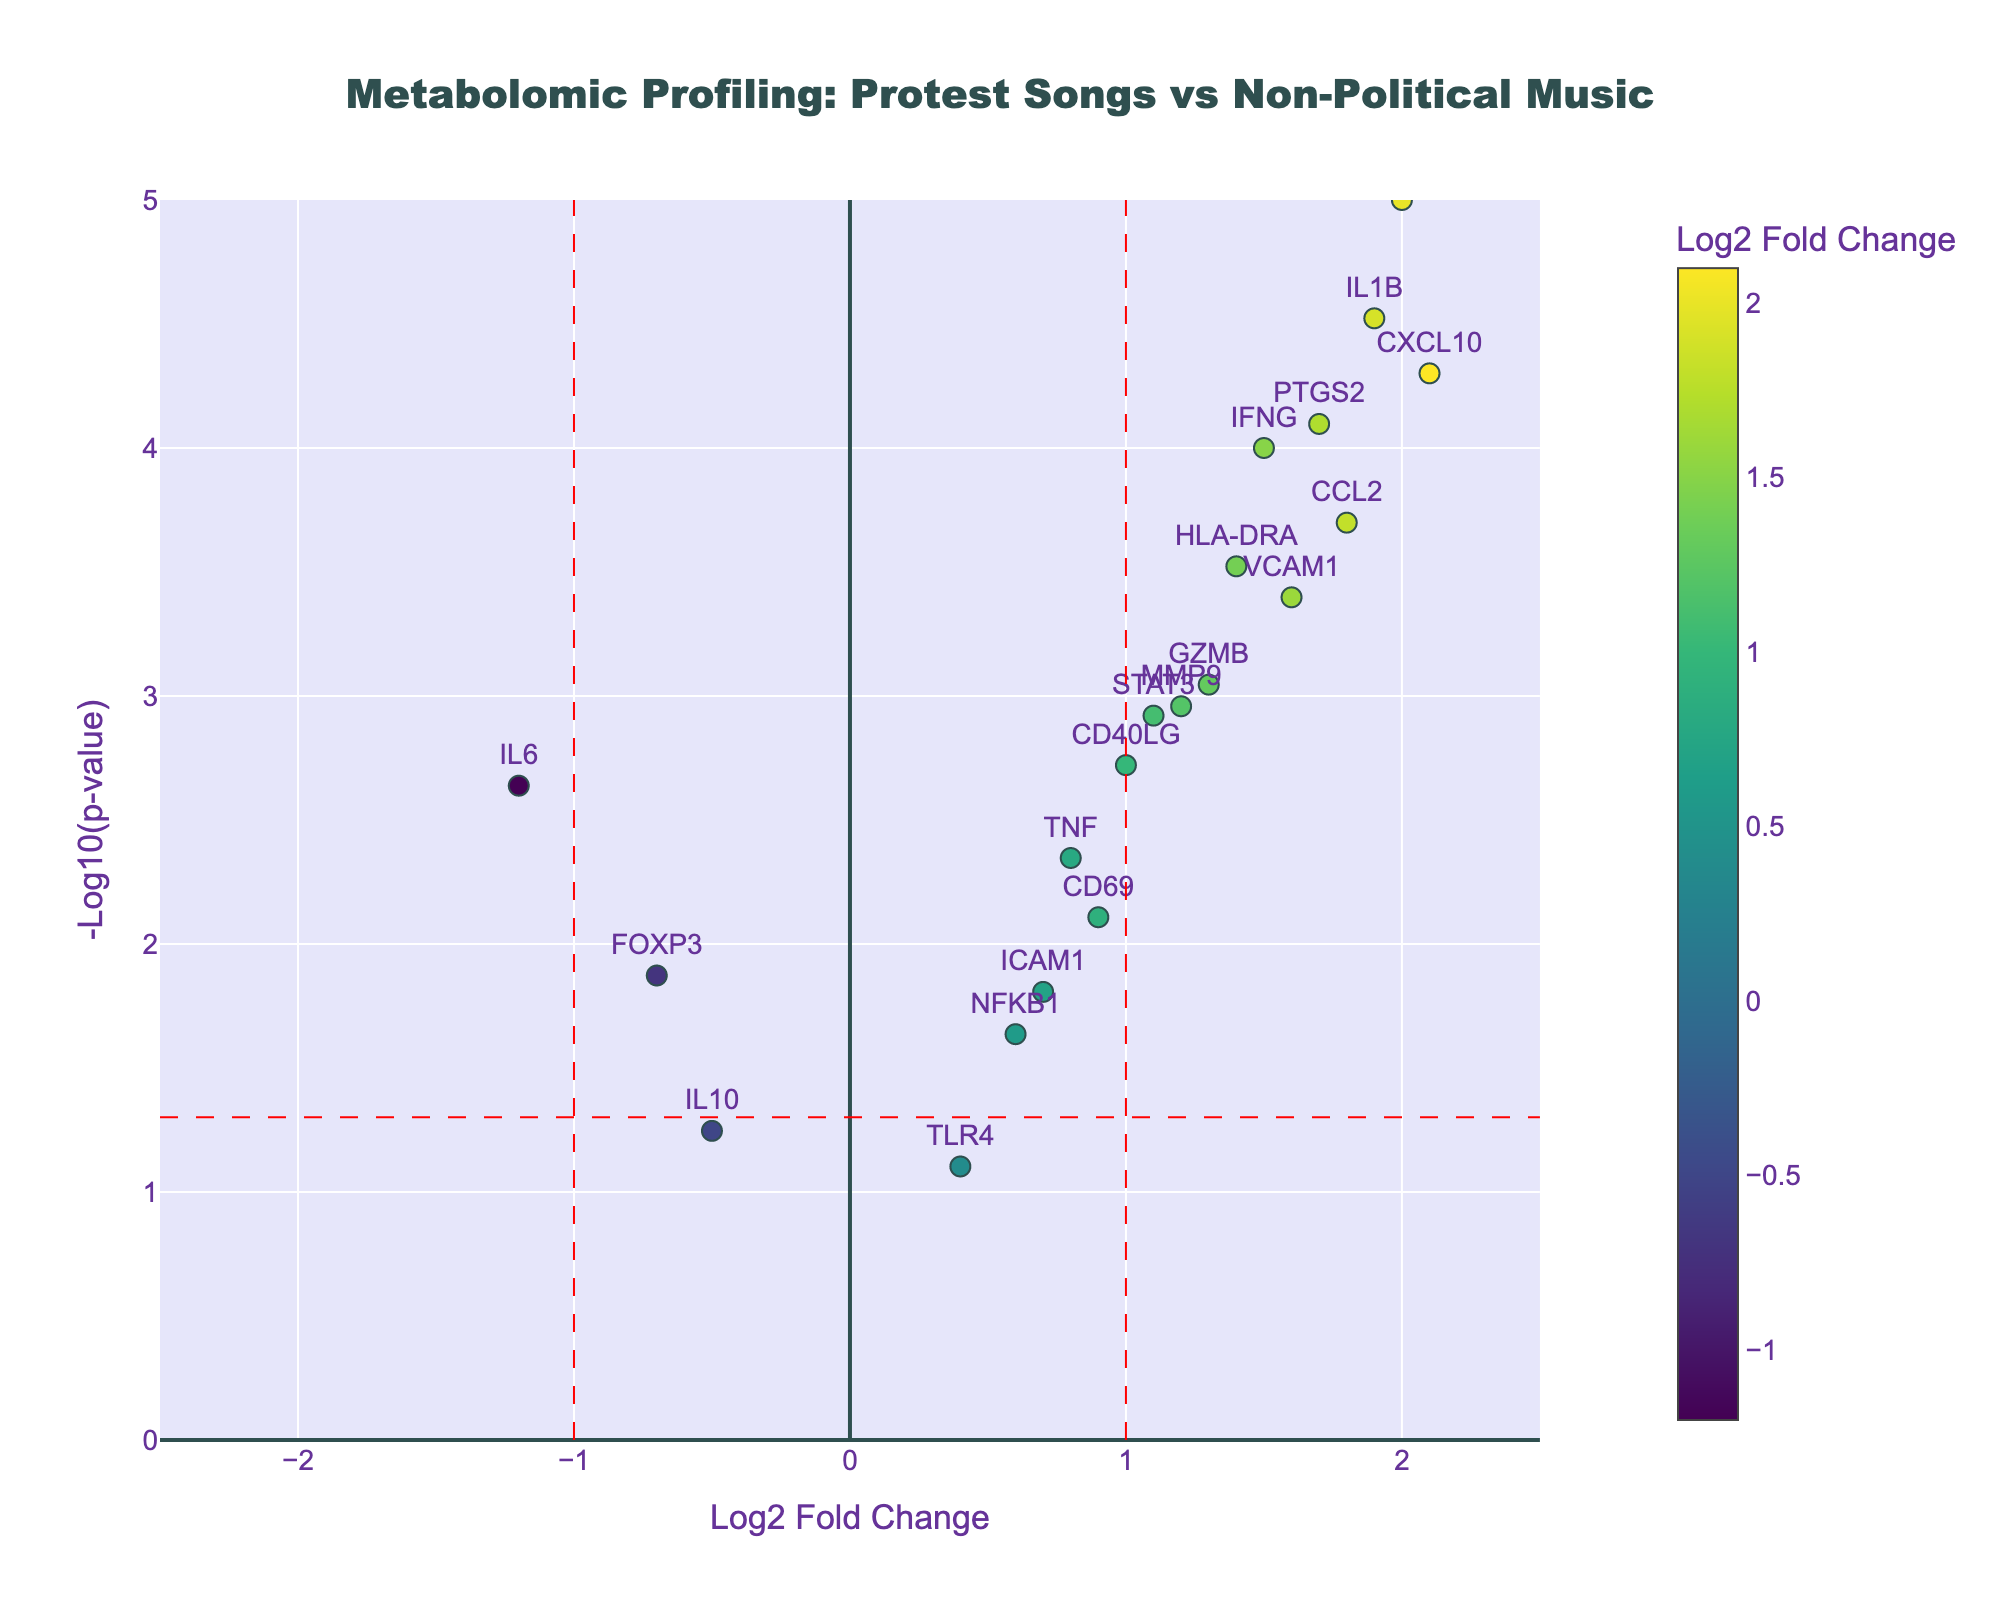what is the title of the figure? The title is prominently displayed at the top center of the figure. By looking at this part, it is clear that the title is "Metabolomic Profiling: Protest Songs vs Non-Political Music".
Answer: Metabolomic Profiling: Protest Songs vs Non-Political Music what does the x-axis represent? The x-axis is labeled "Log2 Fold Change" indicating that it shows the Log2 transformed values of the fold change of each gene.
Answer: Log2 Fold Change what does the y-axis represent? The y-axis is labeled "-Log10(p-value)" which suggests that it displays the negative logarithm base 10 of the p-values for each gene.
Answer: -Log10(p-value) how many genes have a log2 fold change greater than 1? First, identify the vertical lines at Log2 Fold Change = 1. Then, count the data points to the right of this line. These genes include IFNG, CXCL10, CCL2, PTGS2, IL1B, HLA-DRA, and NOS2, making a total of 7.
Answer: 7 which gene has the highest -log10(p-value)? Find the data point with the highest value on the y-axis (-Log10(p-value)). This data point corresponds to the gene NOS2. Therefore, NOS2 has the highest -log10(p-value).
Answer: NOS2 is there any gene with a log2 fold change of less than -1? Refer to the vertical line at Log2 Fold Change = -1. Then look to the left of this line to find any data points. There is one point that qualifies, which is IL6.
Answer: Yes, IL6 which genes are considered statistically significant with a p-value less than 0.05? Look for genes above the horizontal red dash line (-log10(p-value) of 0.05). These genes include IFNG, CXCL10, GZMB, CCL2, STAT3, HLA-DRA, CD40LG, PTGS2, IL1B, NOS2, MMP9, VCAM1, and TNF. Therefore, 13 genes are significant.
Answer: 13 how many genes are upregulated (having positive log2 fold change) and statistically significant? First identify the genes with positive Log2 Fold Change above the horizontal red dash line (-log10(p-value) of 0.05). These genes are TNF, IFNG, CXCL10, GZMB, CCL2, STAT3, HLA-DRA, CD40LG, PTGS2, IL1B, NOS2, MMP9, and VCAM1. Thus there are 13 genes.
Answer: 13 which genes have the closest log2 fold change to 0 but are statistically significant with p-value < 0.05? Look for genes that are closest to Log2 Fold Change = 0 but above the horizontal red dash line (-log10(p-value) of 0.05). The most notable is ICAM1, with a log2 fold change of 0.7.
Answer: ICAM1 what is the log2 fold change and p-value of the gene with the lowest -log10(p-value) among the significant genes? Identify the significant genes (above the horizontal red dash line) and then find the one with the lowest value on the y-axis. That would be ICAM1. Its log2 Fold Change is 0.7, and its p-value is 0.0156.
Answer: 0.7, 0.0156 